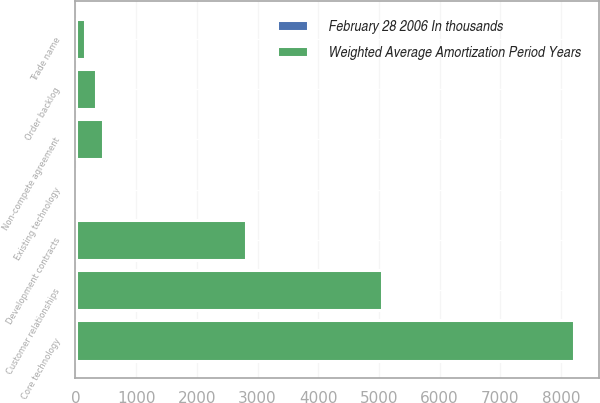Convert chart to OTSL. <chart><loc_0><loc_0><loc_500><loc_500><stacked_bar_chart><ecel><fcel>Customer relationships<fcel>Existing technology<fcel>Core technology<fcel>Development contracts<fcel>Non-compete agreement<fcel>Trade name<fcel>Order backlog<nl><fcel>Weighted Average Amortization Period Years<fcel>5050<fcel>8<fcel>8200<fcel>2810<fcel>450<fcel>160<fcel>340<nl><fcel>February 28 2006 In thousands<fcel>7<fcel>6<fcel>8<fcel>6<fcel>2<fcel>1<fcel>1<nl></chart> 